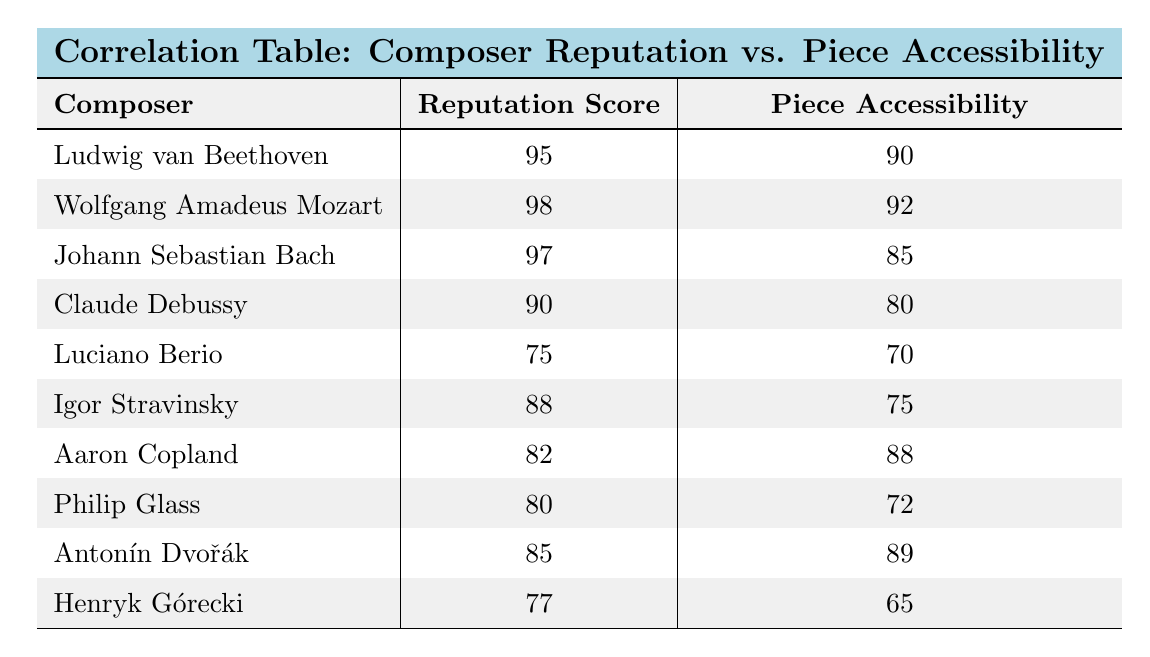What is the piece accessibility score for Luciano Berio? According to the table, the piece accessibility score listed for Luciano Berio is 70.
Answer: 70 Which composer has the highest reputation score? By examining the reputation scores, we find that Wolfgang Amadeus Mozart has the highest score of 98.
Answer: Wolfgang Amadeus Mozart What is the difference in piece accessibility between Beethoven and Debussy? The piece accessibility for Beethoven is 90 and for Debussy is 80. The difference is calculated as 90 - 80 = 10.
Answer: 10 Is the reputation score of Philip Glass higher than that of Igor Stravinsky? Philip Glass has a reputation score of 80, while Igor Stravinsky has a score of 88. Since 80 is less than 88, the statement is false.
Answer: No What is the average reputation score of all the composers listed? Adding up the reputation scores: 95 + 98 + 97 + 90 + 75 + 88 + 82 + 80 + 85 + 77 =  747. There are 10 composers, so the average is 747 / 10 = 74.7.
Answer: 74.7 Which composer's scores indicate a stronger correlation between reputation and accessibility, Beethoven or Berio? Beethoven has a high reputation score of 95 and a piece accessibility score of 90, reflecting a high correlation; Berio has a lower reputation score of 75 and piece accessibility of 70, indicating a weaker correlation. Therefore, Beethoven shows a stronger correlation.
Answer: Beethoven Is the piece accessibility score of Aaron Copland higher than that of Johann Sebastian Bach? Aaron Copland has a piece accessibility score of 88, while Johann Sebastian Bach has a score of 85. Since 88 is greater than 85, the answer is yes.
Answer: Yes What is the total piece accessibility score of all the composers? The scores for piece accessibility are: 90 + 92 + 85 + 80 + 70 + 75 + 88 + 72 + 89 + 65 =  885.
Answer: 885 